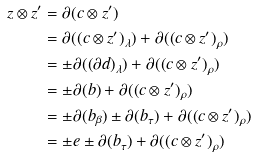<formula> <loc_0><loc_0><loc_500><loc_500>z \otimes z ^ { \prime } & = \partial ( c \otimes z ^ { \prime } ) \\ & = \partial ( ( c \otimes z ^ { \prime } ) _ { \lambda } ) + \partial ( ( c \otimes z ^ { \prime } ) _ { \rho } ) \\ & = \pm \partial ( ( \partial d ) _ { \lambda } ) + \partial ( ( c \otimes z ^ { \prime } ) _ { \rho } ) \\ & = \pm \partial ( b ) + \partial ( ( c \otimes z ^ { \prime } ) _ { \rho } ) \\ & = \pm \partial ( b _ { \beta } ) \pm \partial ( b _ { \tau } ) + \partial ( ( c \otimes z ^ { \prime } ) _ { \rho } ) \\ & = \pm e \pm \partial ( b _ { \tau } ) + \partial ( ( c \otimes z ^ { \prime } ) _ { \rho } )</formula> 